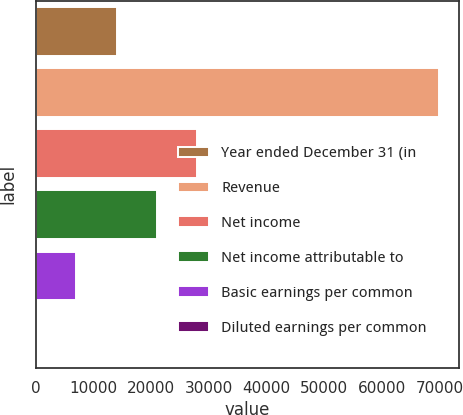Convert chart to OTSL. <chart><loc_0><loc_0><loc_500><loc_500><bar_chart><fcel>Year ended December 31 (in<fcel>Revenue<fcel>Net income<fcel>Net income attributable to<fcel>Basic earnings per common<fcel>Diluted earnings per common<nl><fcel>13974.6<fcel>69860<fcel>27946<fcel>20960.3<fcel>6988.91<fcel>3.23<nl></chart> 